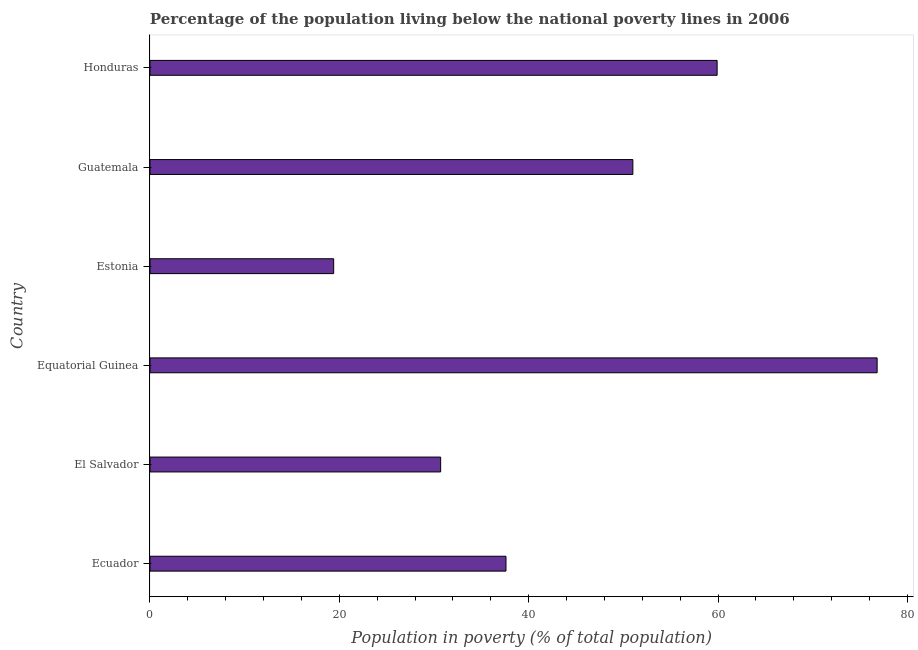Does the graph contain any zero values?
Offer a very short reply. No. What is the title of the graph?
Offer a terse response. Percentage of the population living below the national poverty lines in 2006. What is the label or title of the X-axis?
Your answer should be compact. Population in poverty (% of total population). What is the percentage of population living below poverty line in Honduras?
Make the answer very short. 59.9. Across all countries, what is the maximum percentage of population living below poverty line?
Provide a succinct answer. 76.8. Across all countries, what is the minimum percentage of population living below poverty line?
Offer a terse response. 19.4. In which country was the percentage of population living below poverty line maximum?
Offer a very short reply. Equatorial Guinea. In which country was the percentage of population living below poverty line minimum?
Offer a terse response. Estonia. What is the sum of the percentage of population living below poverty line?
Your answer should be very brief. 275.4. What is the difference between the percentage of population living below poverty line in Estonia and Guatemala?
Offer a very short reply. -31.6. What is the average percentage of population living below poverty line per country?
Ensure brevity in your answer.  45.9. What is the median percentage of population living below poverty line?
Your response must be concise. 44.3. In how many countries, is the percentage of population living below poverty line greater than 16 %?
Keep it short and to the point. 6. What is the ratio of the percentage of population living below poverty line in Ecuador to that in Equatorial Guinea?
Provide a short and direct response. 0.49. Is the percentage of population living below poverty line in Guatemala less than that in Honduras?
Your answer should be compact. Yes. Is the sum of the percentage of population living below poverty line in Equatorial Guinea and Estonia greater than the maximum percentage of population living below poverty line across all countries?
Your answer should be compact. Yes. What is the difference between the highest and the lowest percentage of population living below poverty line?
Provide a succinct answer. 57.4. In how many countries, is the percentage of population living below poverty line greater than the average percentage of population living below poverty line taken over all countries?
Your response must be concise. 3. Are all the bars in the graph horizontal?
Keep it short and to the point. Yes. How many countries are there in the graph?
Your response must be concise. 6. What is the difference between two consecutive major ticks on the X-axis?
Your answer should be very brief. 20. What is the Population in poverty (% of total population) in Ecuador?
Provide a succinct answer. 37.6. What is the Population in poverty (% of total population) of El Salvador?
Keep it short and to the point. 30.7. What is the Population in poverty (% of total population) of Equatorial Guinea?
Offer a very short reply. 76.8. What is the Population in poverty (% of total population) in Guatemala?
Ensure brevity in your answer.  51. What is the Population in poverty (% of total population) in Honduras?
Make the answer very short. 59.9. What is the difference between the Population in poverty (% of total population) in Ecuador and Equatorial Guinea?
Make the answer very short. -39.2. What is the difference between the Population in poverty (% of total population) in Ecuador and Estonia?
Offer a terse response. 18.2. What is the difference between the Population in poverty (% of total population) in Ecuador and Guatemala?
Offer a terse response. -13.4. What is the difference between the Population in poverty (% of total population) in Ecuador and Honduras?
Keep it short and to the point. -22.3. What is the difference between the Population in poverty (% of total population) in El Salvador and Equatorial Guinea?
Your response must be concise. -46.1. What is the difference between the Population in poverty (% of total population) in El Salvador and Guatemala?
Provide a succinct answer. -20.3. What is the difference between the Population in poverty (% of total population) in El Salvador and Honduras?
Ensure brevity in your answer.  -29.2. What is the difference between the Population in poverty (% of total population) in Equatorial Guinea and Estonia?
Provide a succinct answer. 57.4. What is the difference between the Population in poverty (% of total population) in Equatorial Guinea and Guatemala?
Make the answer very short. 25.8. What is the difference between the Population in poverty (% of total population) in Estonia and Guatemala?
Provide a short and direct response. -31.6. What is the difference between the Population in poverty (% of total population) in Estonia and Honduras?
Make the answer very short. -40.5. What is the difference between the Population in poverty (% of total population) in Guatemala and Honduras?
Provide a short and direct response. -8.9. What is the ratio of the Population in poverty (% of total population) in Ecuador to that in El Salvador?
Give a very brief answer. 1.23. What is the ratio of the Population in poverty (% of total population) in Ecuador to that in Equatorial Guinea?
Your answer should be compact. 0.49. What is the ratio of the Population in poverty (% of total population) in Ecuador to that in Estonia?
Offer a very short reply. 1.94. What is the ratio of the Population in poverty (% of total population) in Ecuador to that in Guatemala?
Provide a short and direct response. 0.74. What is the ratio of the Population in poverty (% of total population) in Ecuador to that in Honduras?
Offer a very short reply. 0.63. What is the ratio of the Population in poverty (% of total population) in El Salvador to that in Estonia?
Offer a very short reply. 1.58. What is the ratio of the Population in poverty (% of total population) in El Salvador to that in Guatemala?
Give a very brief answer. 0.6. What is the ratio of the Population in poverty (% of total population) in El Salvador to that in Honduras?
Ensure brevity in your answer.  0.51. What is the ratio of the Population in poverty (% of total population) in Equatorial Guinea to that in Estonia?
Keep it short and to the point. 3.96. What is the ratio of the Population in poverty (% of total population) in Equatorial Guinea to that in Guatemala?
Your answer should be compact. 1.51. What is the ratio of the Population in poverty (% of total population) in Equatorial Guinea to that in Honduras?
Your answer should be very brief. 1.28. What is the ratio of the Population in poverty (% of total population) in Estonia to that in Guatemala?
Offer a terse response. 0.38. What is the ratio of the Population in poverty (% of total population) in Estonia to that in Honduras?
Provide a short and direct response. 0.32. What is the ratio of the Population in poverty (% of total population) in Guatemala to that in Honduras?
Offer a very short reply. 0.85. 